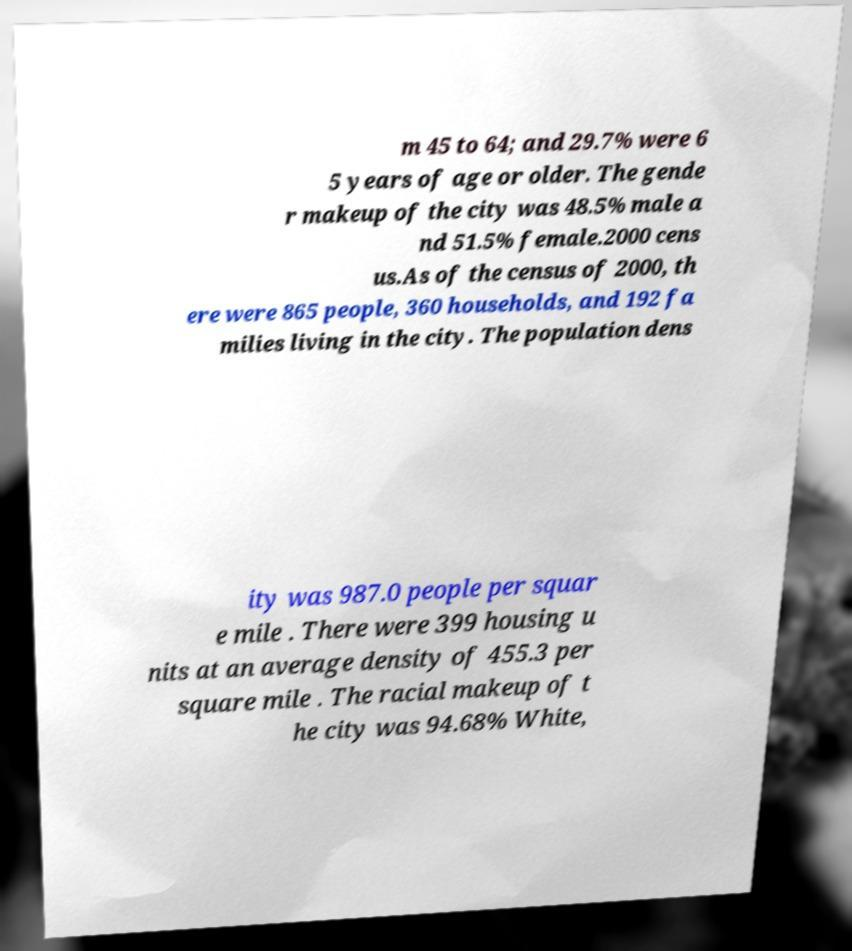Can you read and provide the text displayed in the image?This photo seems to have some interesting text. Can you extract and type it out for me? m 45 to 64; and 29.7% were 6 5 years of age or older. The gende r makeup of the city was 48.5% male a nd 51.5% female.2000 cens us.As of the census of 2000, th ere were 865 people, 360 households, and 192 fa milies living in the city. The population dens ity was 987.0 people per squar e mile . There were 399 housing u nits at an average density of 455.3 per square mile . The racial makeup of t he city was 94.68% White, 